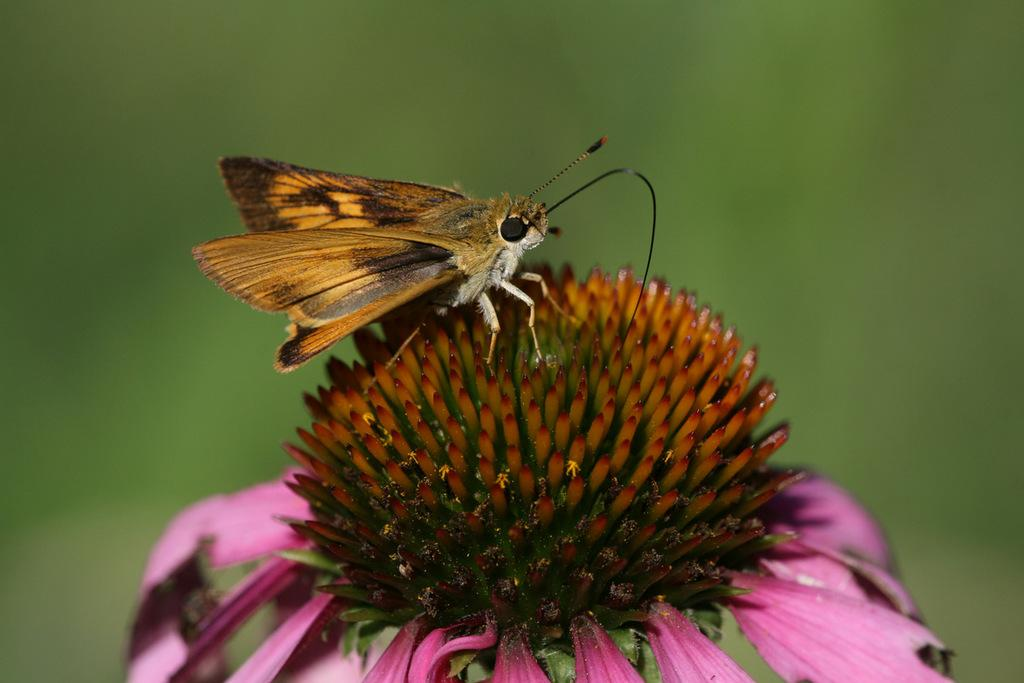What is present in the image? There is a fly and a flower in the image. Where is the fly located in relation to the flower? The fly is on the flower. What is the main focus of the image? The flower is in the center of the image. How far away is the team from the flower in the image? There is no team present in the image, so it's not possible to determine their distance from the flower. 